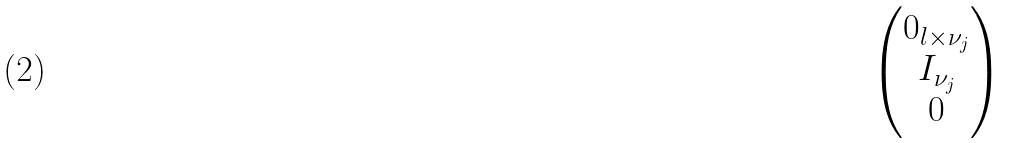Convert formula to latex. <formula><loc_0><loc_0><loc_500><loc_500>\begin{pmatrix} 0 _ { l \times \nu _ { j } } \\ I _ { \nu _ { j } } \\ 0 \end{pmatrix}</formula> 